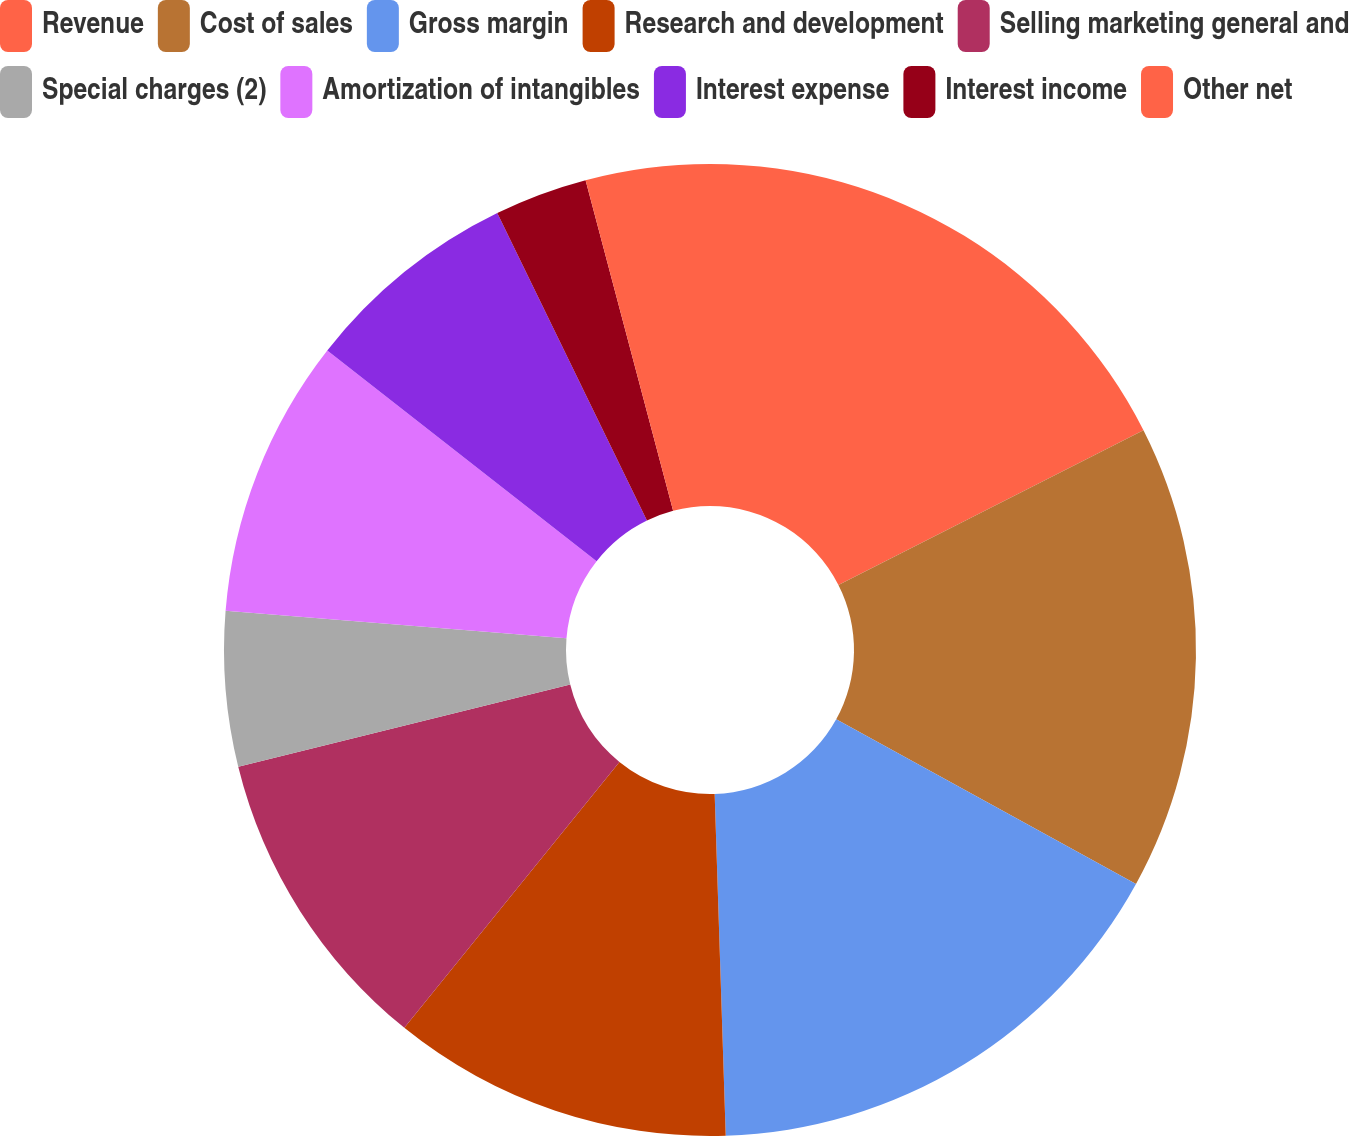Convert chart. <chart><loc_0><loc_0><loc_500><loc_500><pie_chart><fcel>Revenue<fcel>Cost of sales<fcel>Gross margin<fcel>Research and development<fcel>Selling marketing general and<fcel>Special charges (2)<fcel>Amortization of intangibles<fcel>Interest expense<fcel>Interest income<fcel>Other net<nl><fcel>17.53%<fcel>15.46%<fcel>16.49%<fcel>11.34%<fcel>10.31%<fcel>5.15%<fcel>9.28%<fcel>7.22%<fcel>3.09%<fcel>4.12%<nl></chart> 